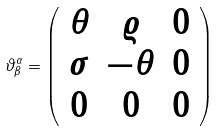<formula> <loc_0><loc_0><loc_500><loc_500>\vartheta ^ { \alpha } _ { \beta } = \left ( \begin{array} { c c c } \theta & \varrho & 0 \\ \sigma & - \theta & 0 \\ 0 & 0 & 0 \end{array} \right )</formula> 